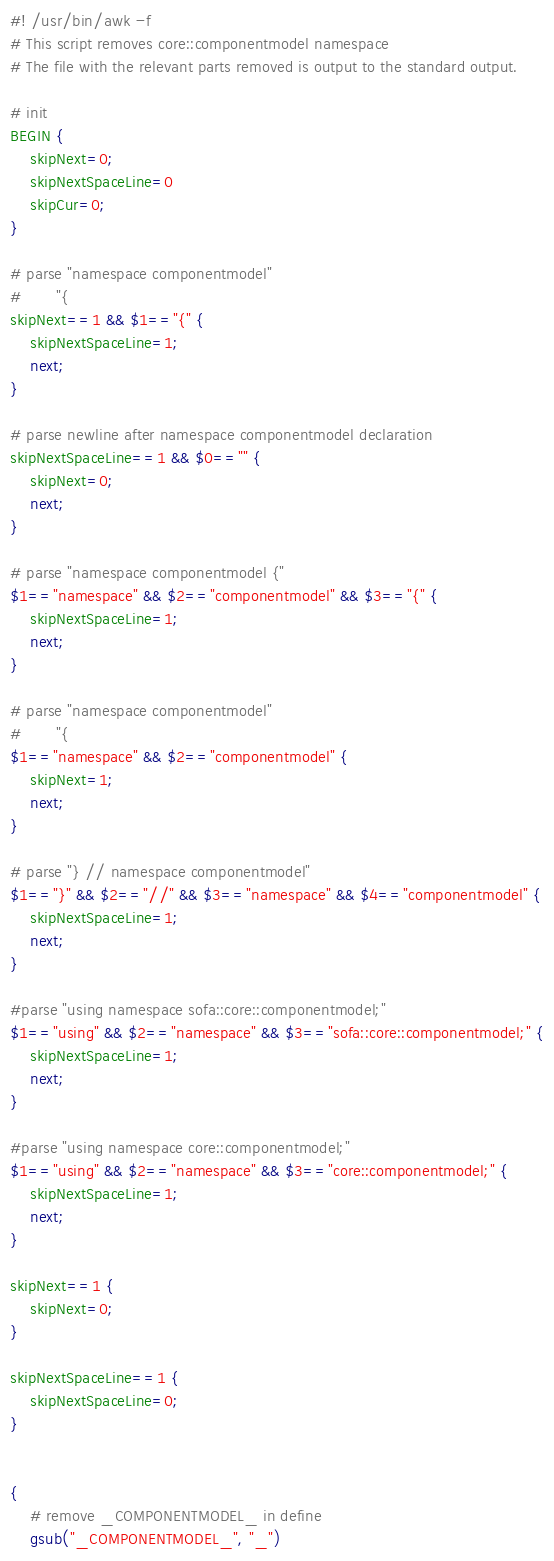<code> <loc_0><loc_0><loc_500><loc_500><_Awk_>#! /usr/bin/awk -f
# This script removes core::componentmodel namespace
# The file with the relevant parts removed is output to the standard output.

# init
BEGIN {
    skipNext=0;
	skipNextSpaceLine=0
	skipCur=0;
}

# parse "namespace componentmodel"
#		"{
skipNext==1 && $1=="{" {
	skipNextSpaceLine=1;
	next;
}

# parse newline after namespace componentmodel declaration
skipNextSpaceLine==1 && $0=="" {
	skipNext=0;
	next;
}

# parse "namespace componentmodel {"
$1=="namespace" && $2=="componentmodel" && $3=="{" {
	skipNextSpaceLine=1;
	next;
}

# parse "namespace componentmodel"
#		"{
$1=="namespace" && $2=="componentmodel" {
	skipNext=1;
    next;
}

# parse "} // namespace componentmodel"
$1=="}" && $2=="//" && $3=="namespace" && $4=="componentmodel" {
	skipNextSpaceLine=1;
	next;
}

#parse "using namespace sofa::core::componentmodel;"
$1=="using" && $2=="namespace" && $3=="sofa::core::componentmodel;" {
	skipNextSpaceLine=1;
	next;
}

#parse "using namespace core::componentmodel;"
$1=="using" && $2=="namespace" && $3=="core::componentmodel;" {
	skipNextSpaceLine=1;
	next;
}

skipNext==1 {
	skipNext=0; 
}

skipNextSpaceLine==1 {
	skipNextSpaceLine=0;
}


{
	# remove _COMPONENTMODEL_ in define
	gsub("_COMPONENTMODEL_", "_")</code> 